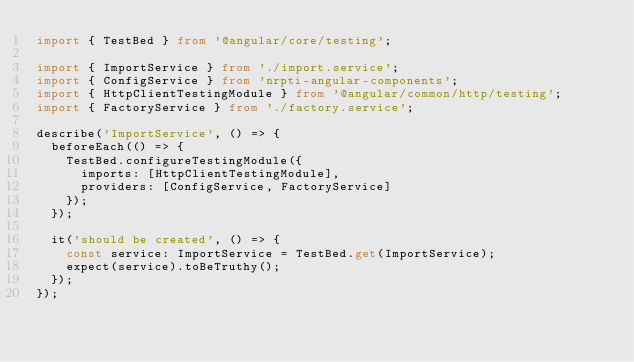<code> <loc_0><loc_0><loc_500><loc_500><_TypeScript_>import { TestBed } from '@angular/core/testing';

import { ImportService } from './import.service';
import { ConfigService } from 'nrpti-angular-components';
import { HttpClientTestingModule } from '@angular/common/http/testing';
import { FactoryService } from './factory.service';

describe('ImportService', () => {
  beforeEach(() => {
    TestBed.configureTestingModule({
      imports: [HttpClientTestingModule],
      providers: [ConfigService, FactoryService]
    });
  });

  it('should be created', () => {
    const service: ImportService = TestBed.get(ImportService);
    expect(service).toBeTruthy();
  });
});
</code> 